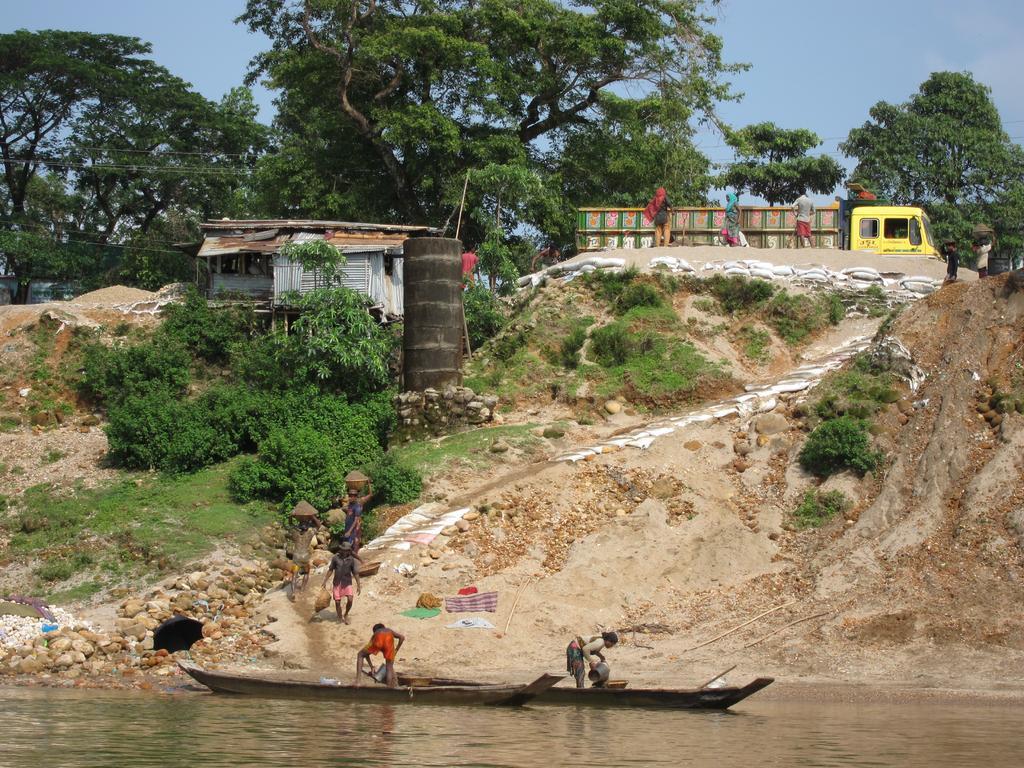Describe this image in one or two sentences. At the bottom of the image there are boats on the water and we can see people standing in the boats. In the background there are people, shed, vehicle, trees and sky. 